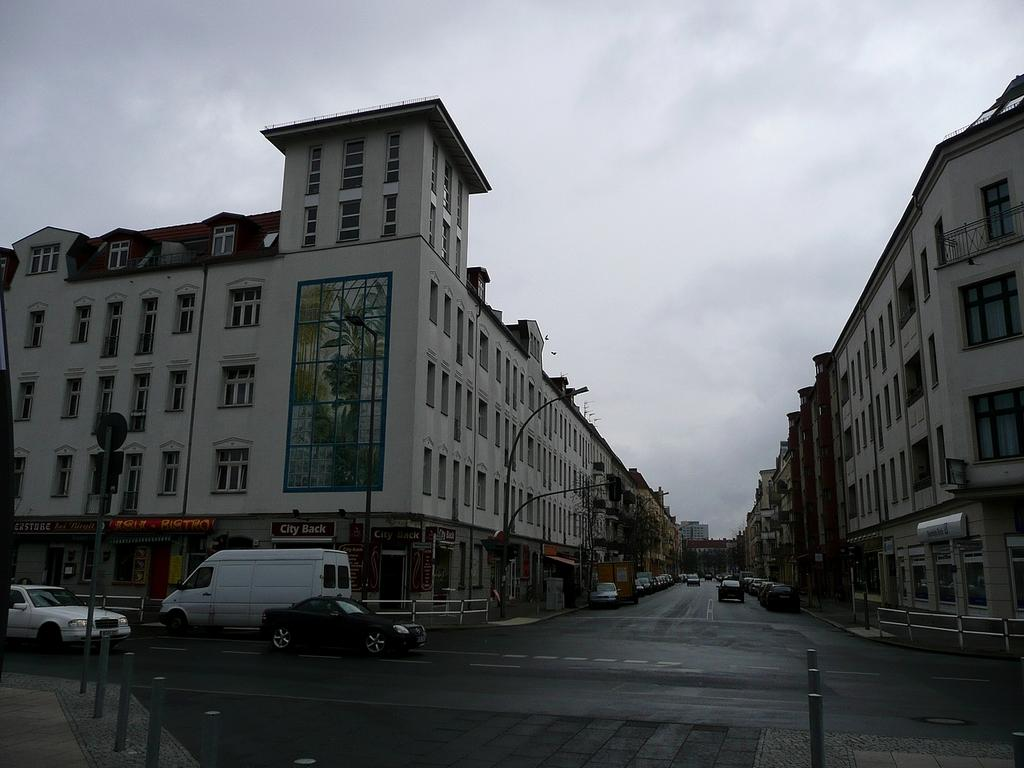What is the main feature of the image? There is a road in the image. What is happening on the road? There are cars on the road. What else can be seen in the image besides the road and cars? There are poles, buildings, and the sky visible in the image. What is the condition of the sky in the image? The sky is visible in the background of the image, and there are clouds in the sky. What grade is the parcel being delivered to in the image? There is no parcel or indication of a delivery in the image. What type of destruction can be seen in the image? There is no destruction present in the image; it features a road, cars, poles, buildings, and a sky with clouds. 